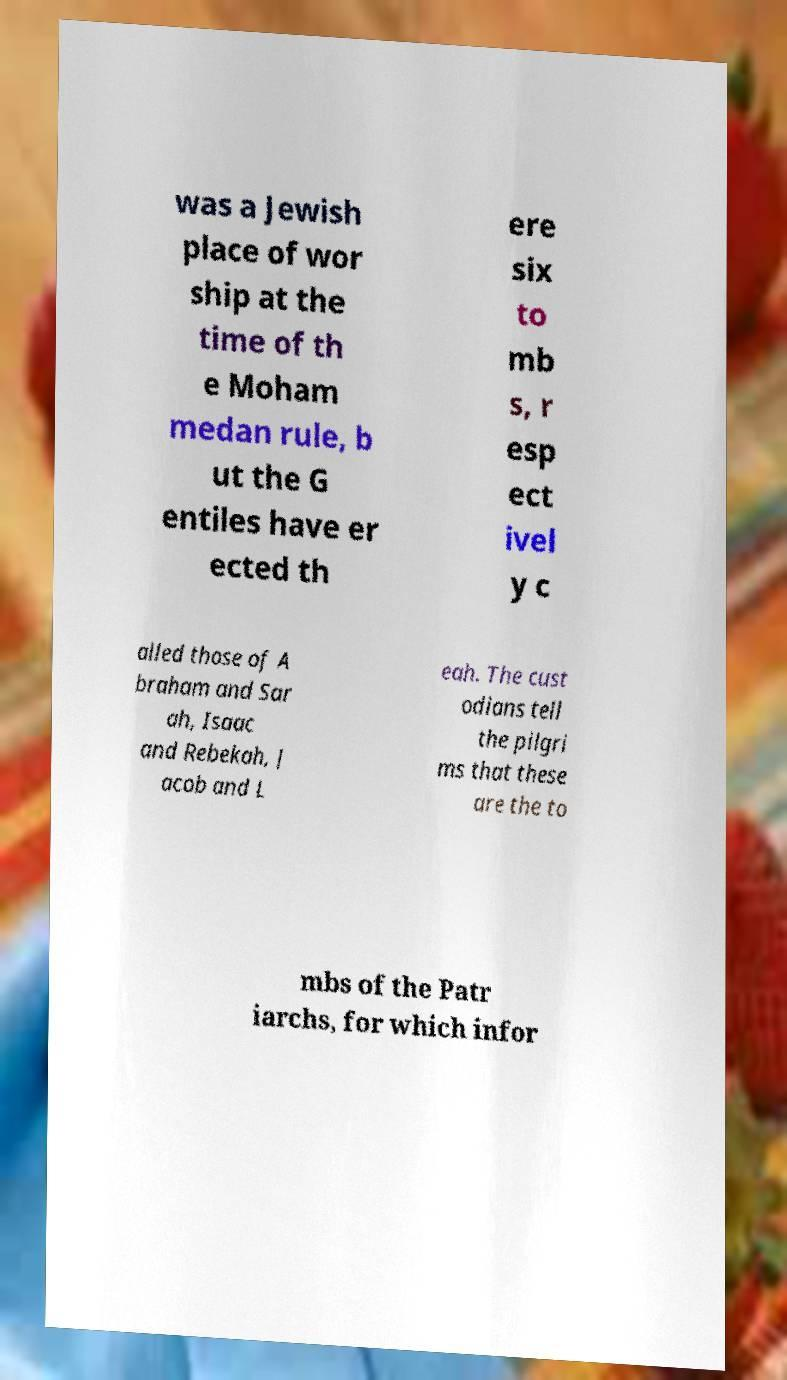For documentation purposes, I need the text within this image transcribed. Could you provide that? was a Jewish place of wor ship at the time of th e Moham medan rule, b ut the G entiles have er ected th ere six to mb s, r esp ect ivel y c alled those of A braham and Sar ah, Isaac and Rebekah, J acob and L eah. The cust odians tell the pilgri ms that these are the to mbs of the Patr iarchs, for which infor 